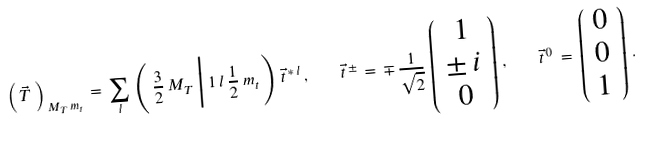<formula> <loc_0><loc_0><loc_500><loc_500>\left ( \, \vec { T } \, \right ) _ { \, M _ { T } \, m _ { t } } \, = \, \sum _ { l } \, \left ( \, \frac { 3 } { 2 } \, M _ { T } \, \Big | \, 1 \, l \, \frac { 1 } { 2 } \, m _ { t } \, \right ) \, \vec { t } ^ { \, * \, l } \, , \quad \vec { t } ^ { \, \pm } \, = \, \mp \, \frac { 1 } { \sqrt { 2 } } \, \left ( \begin{array} { c } 1 \\ \pm \, i \\ 0 \end{array} \right ) \, , \quad \vec { t } ^ { \, 0 } \, = \, \left ( \begin{array} { c } 0 \\ 0 \\ 1 \end{array} \right ) \, .</formula> 